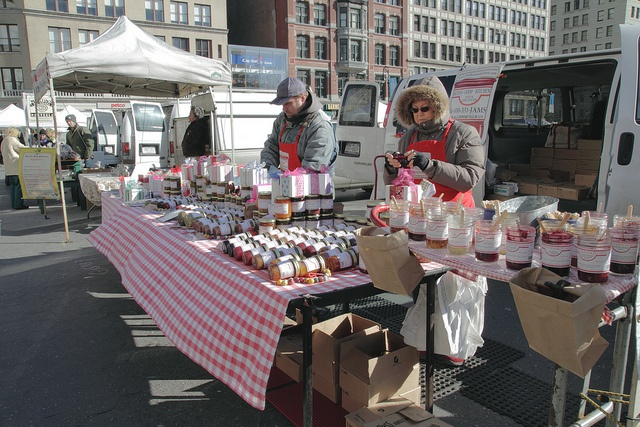Describe the objects in this image and their specific colors. I can see dining table in gray, darkgray, brown, and black tones, truck in gray and black tones, dining table in gray, darkgray, and black tones, people in gray, darkgray, black, and maroon tones, and truck in gray, white, darkgray, and black tones in this image. 